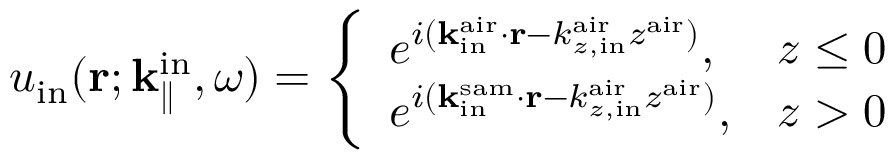Convert formula to latex. <formula><loc_0><loc_0><loc_500><loc_500>u _ { i n } ( { r } ; { k } _ { \| } ^ { i n } , \omega ) = \left \{ \begin{array} { l l } { e ^ { i ( { k } _ { i n } ^ { a i r } \cdot { r } - k _ { z , i n } ^ { a i r } z ^ { a i r } ) } , } & { z \leq 0 } \\ { e ^ { i ( { k } _ { i n } ^ { s a m } \cdot { r } - k _ { z , i n } ^ { a i r } z ^ { a i r } ) } , } & { z > 0 } \end{array}</formula> 